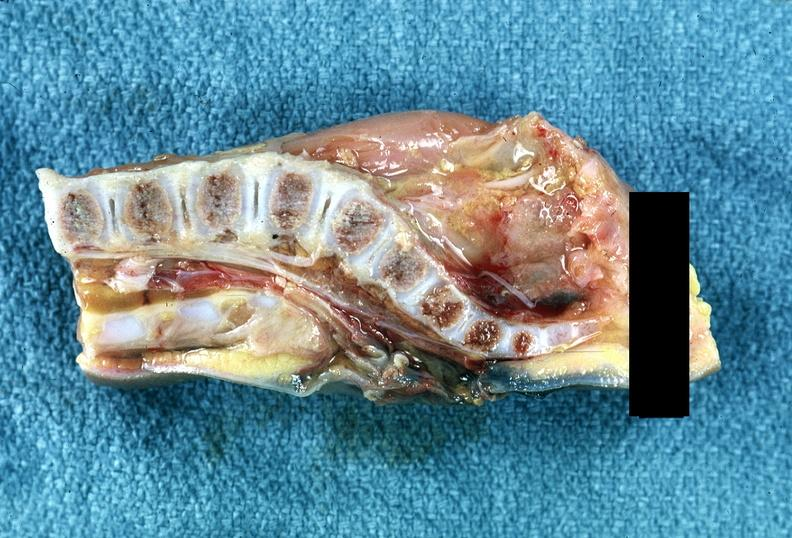s this lesion present?
Answer the question using a single word or phrase. No 